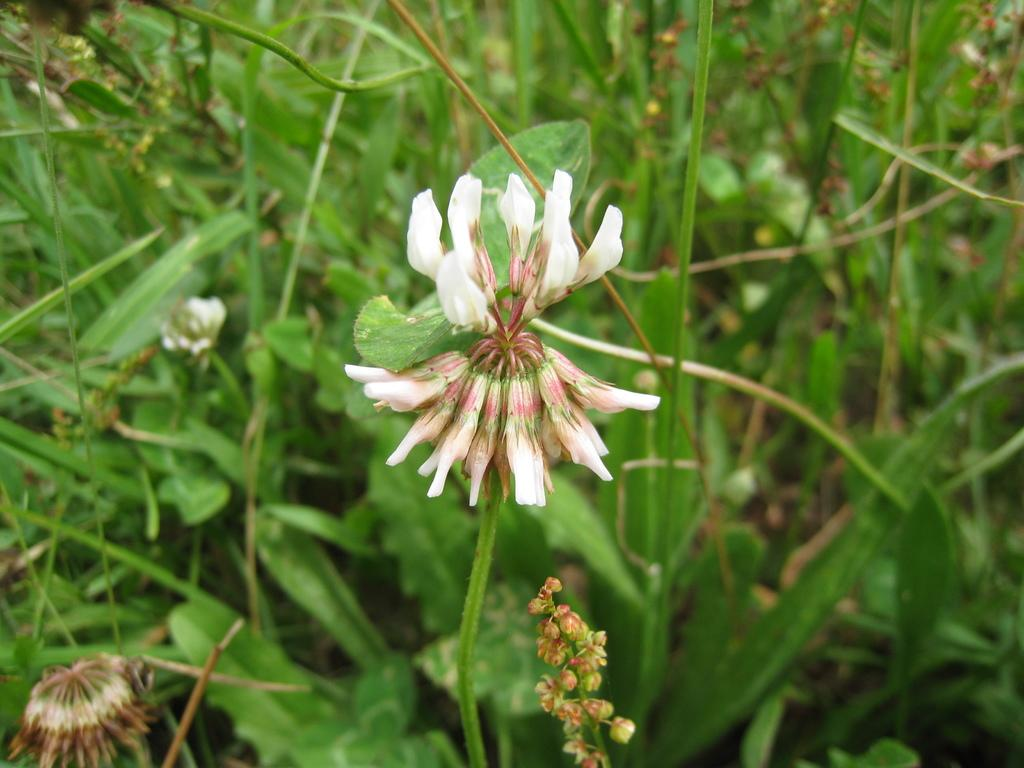What type of living organisms can be seen in the image? Plants can be seen in the image. Do the plants have any specific features? Yes, the plants have flowers. Where are the plants and flowers located in the image? The plants and flowers are on the ground. What type of shoe is being used as a representative for the plants in the image? There is no shoe present in the image, and the plants are not being represented by any other object. 